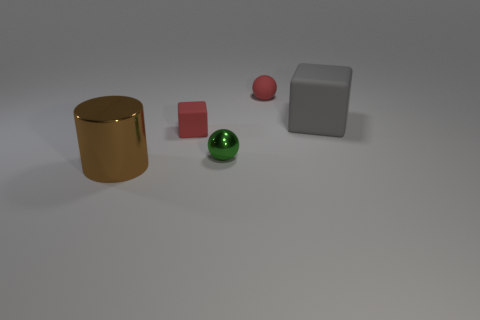How many brown objects are in front of the block that is to the right of the tiny red thing to the right of the green sphere?
Your answer should be very brief. 1. There is another thing that is the same shape as the gray object; what material is it?
Keep it short and to the point. Rubber. Is there anything else that is made of the same material as the cylinder?
Offer a very short reply. Yes. What color is the tiny rubber ball that is behind the small shiny ball?
Offer a very short reply. Red. Is the material of the big cube the same as the sphere that is in front of the tiny matte cube?
Make the answer very short. No. What material is the gray object?
Offer a terse response. Rubber. There is a brown thing that is made of the same material as the tiny green sphere; what is its shape?
Make the answer very short. Cylinder. How many other objects are the same shape as the large brown thing?
Your answer should be very brief. 0. There is a gray block; how many large objects are left of it?
Provide a short and direct response. 1. There is a red matte thing that is in front of the tiny rubber ball; does it have the same size as the ball that is right of the green metallic thing?
Your answer should be compact. Yes. 